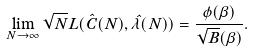Convert formula to latex. <formula><loc_0><loc_0><loc_500><loc_500>\lim _ { N \to \infty } \sqrt { N } L ( \hat { C } ( N ) , \hat { \lambda } ( N ) ) = \frac { \phi ( \beta ) } { \sqrt { B } \Phi ( \beta ) } .</formula> 